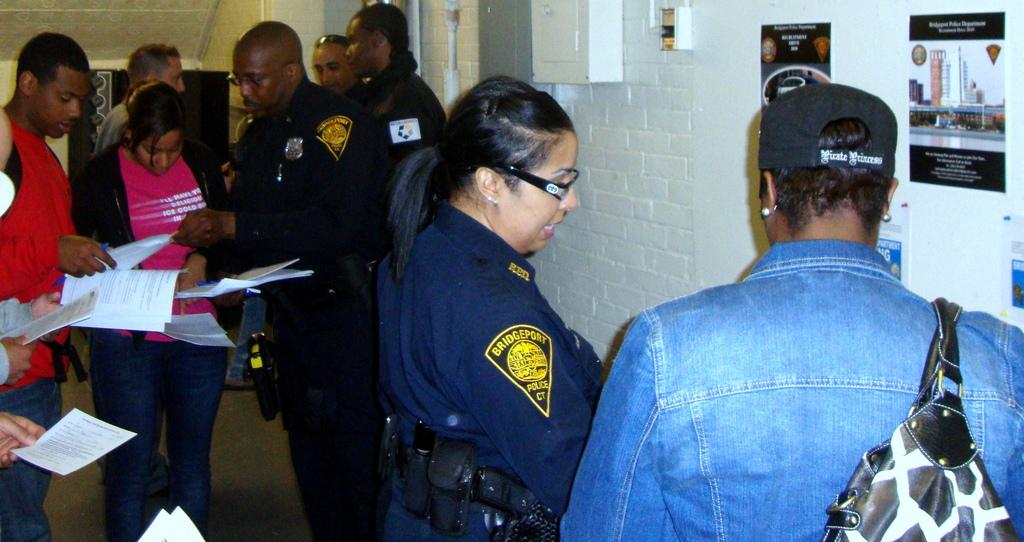What are the persons in the image doing? The persons in the image are standing on the floor and holding papers in their hands. What else are the persons holding in the image? The persons are also holding pens. What can be seen on the wall in the image? There are posters on the wall. What is the background of the image? The background of the image includes a wall with posters on it. How many insects can be seen crawling on the persons in the image? There are no insects visible in the image; the persons are holding papers and pens. 